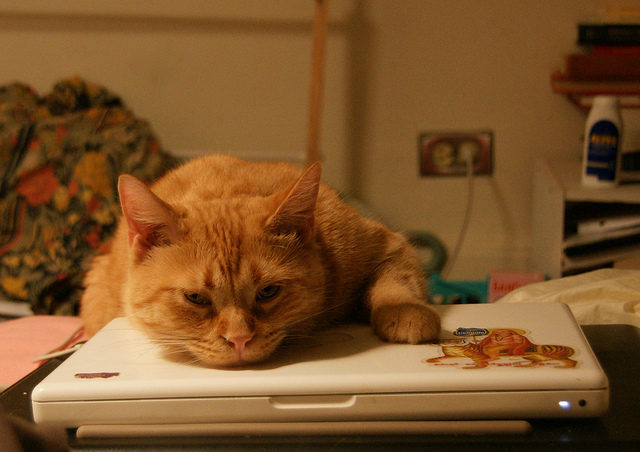<image>What brand is the bottle in the background? I am not sure of the brand of the bottle in the background. It can be 'aleve' or 'advil'. What brand is the bottle in the background? The bottle in the background is most likely Aleve. 